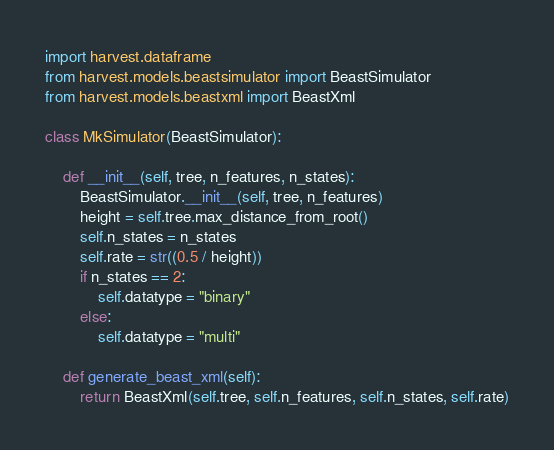<code> <loc_0><loc_0><loc_500><loc_500><_Python_>import harvest.dataframe
from harvest.models.beastsimulator import BeastSimulator
from harvest.models.beastxml import BeastXml

class MkSimulator(BeastSimulator):

    def __init__(self, tree, n_features, n_states):
        BeastSimulator.__init__(self, tree, n_features)
        height = self.tree.max_distance_from_root()
        self.n_states = n_states
        self.rate = str((0.5 / height))
        if n_states == 2:
            self.datatype = "binary"
        else:
            self.datatype = "multi"

    def generate_beast_xml(self):
        return BeastXml(self.tree, self.n_features, self.n_states, self.rate)
</code> 